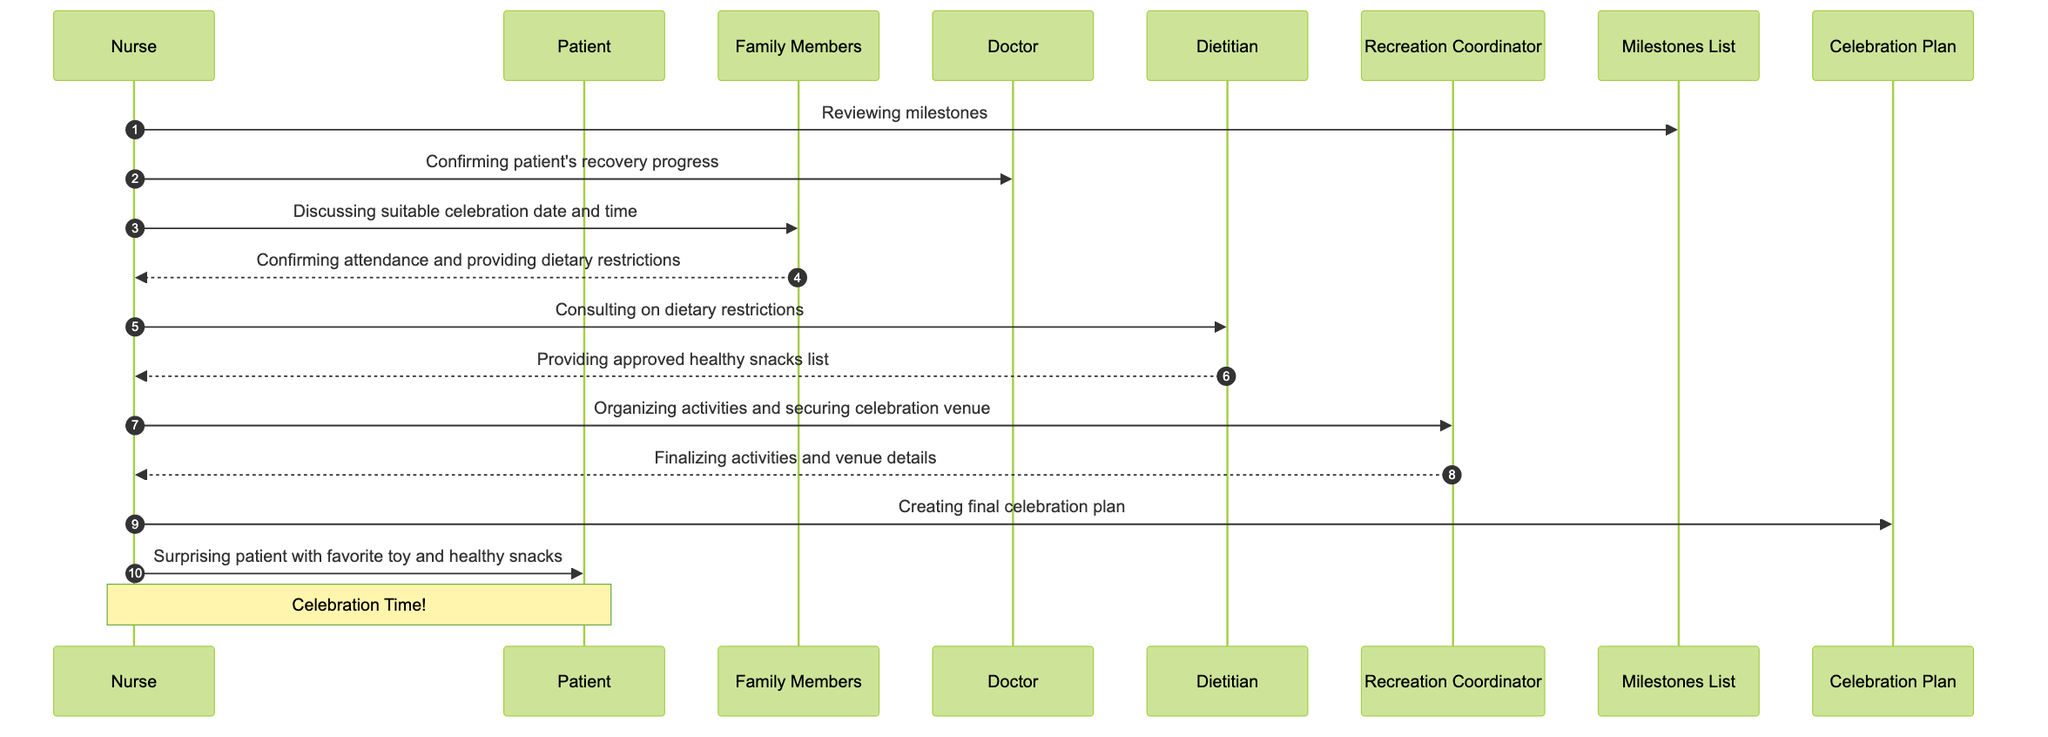What is the first message sent in the sequence? The first message sent is from the Nurse to the Milestones List, indicating that the Nurse is reviewing the milestones. This can be identified as the first arrow in the diagram, marked by the numbering system of the sequence.
Answer: Reviewing milestones How many actors are involved in the celebration process? The diagram lists six distinct actors involved in the celebration: Nurse, Patient, Family Members, Doctor, Dietitian, and Recreation Coordinator. By counting these unique participants, we arrive at the total.
Answer: Six Who provides the approved healthy snacks list? The Dietitian sends the approved healthy snacks list to the Nurse after the Nurse consults on dietary restrictions. This is shown by the back-and-forth messages between these two actors.
Answer: Dietitian What does the Nurse surprise the Patient with? According to the final message from the Nurse to the Patient, the Nurse surprises the Patient with the favorite toy and healthy snacks, which is explicitly mentioned in that message.
Answer: Patient's Favorite Toy and Healthy Snacks What is the role of the Recreation Coordinator in the sequence? The Recreation Coordinator organizes activities and secures the celebration venue, as indicated by the messages exchanged between the Nurse and the Recreation Coordinator. This illustrates their supportive role in the celebration planning.
Answer: Organizing activities and securing celebration venue What follows after the Nurse discusses the celebration date and time? Following the Nurse’s discussion with Family Members about the celebration date and time, the Family Members confirm their attendance and provide dietary restrictions. This can be traced as the immediate next message in the flow.
Answer: Confirming attendance and providing dietary restrictions How does the diagram conclude? The diagram concludes with a note indicating "Celebration Time!" after the Nurse surprises the Patient with their favorite toy and healthy snacks. This emphasizes the successful completion of the celebration preparations.
Answer: Celebration Time! What is the last object mentioned in the sequence? The last object mentioned in the sequence is the Celebration Plan, which the Nurse creates as part of the final steps to organize the celebration. This is the last object that interacts with the Nurse.
Answer: Celebration Plan What interaction comes after the Nurse confirms the patient's recovery progress? After confirming the patient's recovery progress with the Doctor, the Nurse discusses the suitable celebration date and time with the Family Members. This is a direct follow-up in the message sequence.
Answer: Discussing suitable celebration date and time 